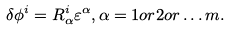Convert formula to latex. <formula><loc_0><loc_0><loc_500><loc_500>\delta \phi ^ { i } = R _ { \alpha } ^ { i } \varepsilon ^ { \alpha } , \alpha = 1 o r 2 o r \dots m .</formula> 